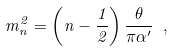<formula> <loc_0><loc_0><loc_500><loc_500>m _ { n } ^ { 2 } = \left ( n - \frac { 1 } { 2 } \right ) \frac { \theta } { \pi \alpha ^ { \prime } } \ ,</formula> 